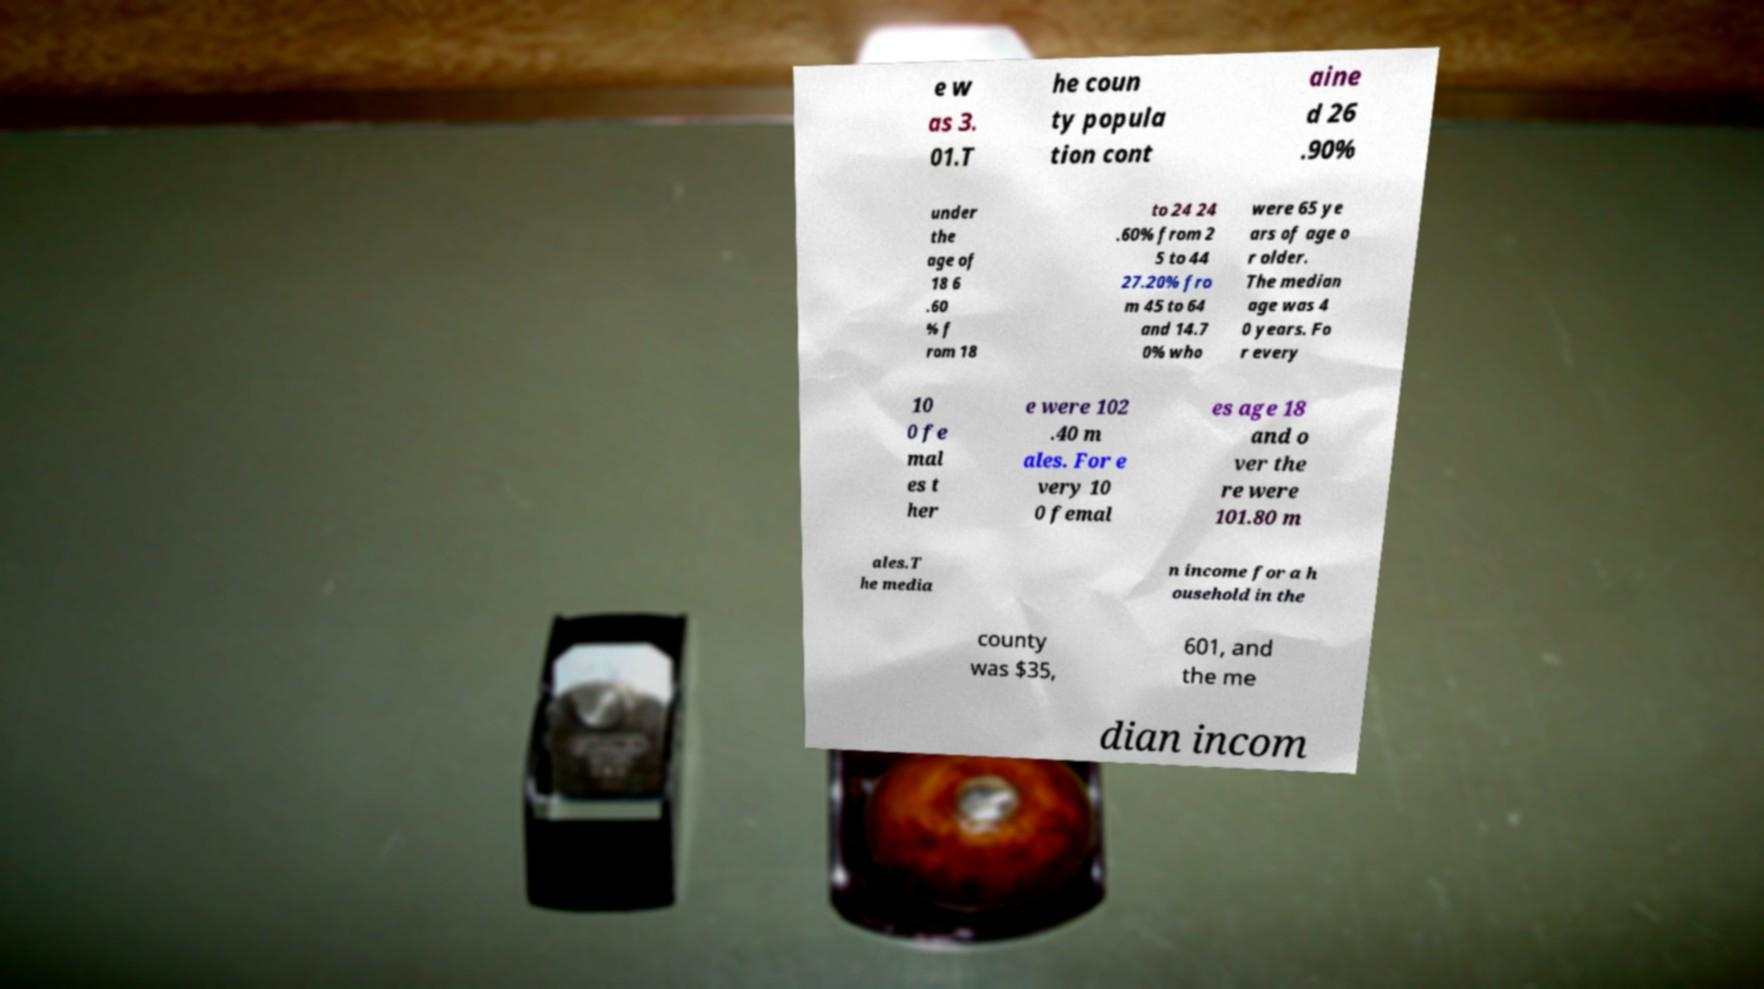For documentation purposes, I need the text within this image transcribed. Could you provide that? e w as 3. 01.T he coun ty popula tion cont aine d 26 .90% under the age of 18 6 .60 % f rom 18 to 24 24 .60% from 2 5 to 44 27.20% fro m 45 to 64 and 14.7 0% who were 65 ye ars of age o r older. The median age was 4 0 years. Fo r every 10 0 fe mal es t her e were 102 .40 m ales. For e very 10 0 femal es age 18 and o ver the re were 101.80 m ales.T he media n income for a h ousehold in the county was $35, 601, and the me dian incom 